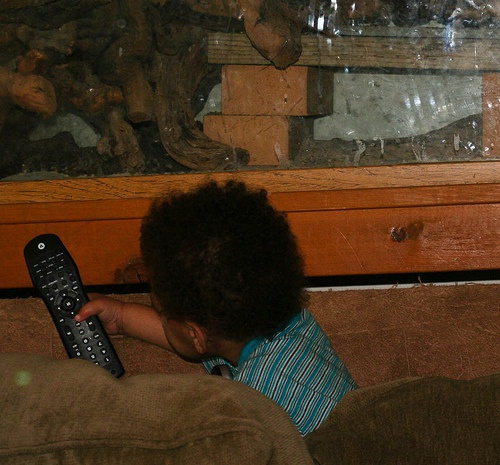Describe the objects in this image and their specific colors. I can see couch in black, maroon, and gray tones, people in black, maroon, teal, and gray tones, and remote in black, gray, maroon, and darkgray tones in this image. 